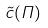<formula> <loc_0><loc_0><loc_500><loc_500>\tilde { c } ( \Pi )</formula> 